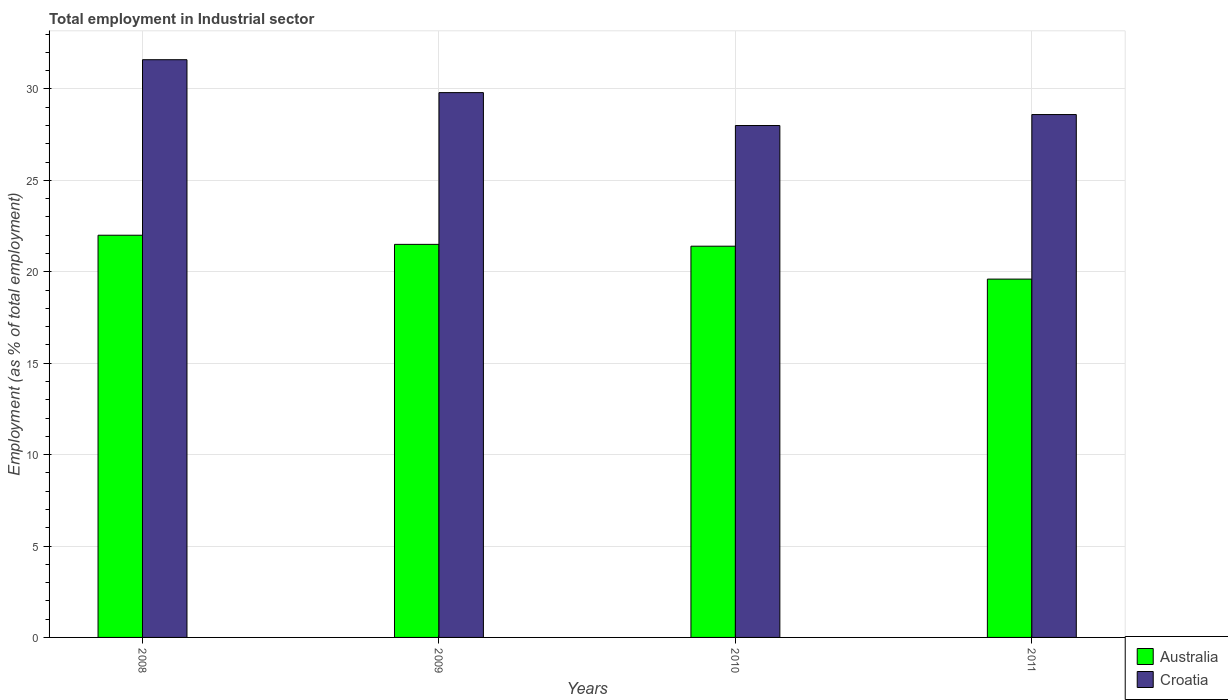How many groups of bars are there?
Make the answer very short. 4. Are the number of bars on each tick of the X-axis equal?
Offer a terse response. Yes. How many bars are there on the 1st tick from the right?
Keep it short and to the point. 2. What is the label of the 3rd group of bars from the left?
Offer a very short reply. 2010. In how many cases, is the number of bars for a given year not equal to the number of legend labels?
Provide a succinct answer. 0. What is the employment in industrial sector in Croatia in 2010?
Offer a very short reply. 28. Across all years, what is the minimum employment in industrial sector in Australia?
Provide a short and direct response. 19.6. What is the total employment in industrial sector in Croatia in the graph?
Provide a succinct answer. 118. What is the difference between the employment in industrial sector in Australia in 2009 and that in 2010?
Keep it short and to the point. 0.1. What is the difference between the employment in industrial sector in Croatia in 2011 and the employment in industrial sector in Australia in 2009?
Offer a terse response. 7.1. What is the average employment in industrial sector in Australia per year?
Your answer should be compact. 21.12. In the year 2008, what is the difference between the employment in industrial sector in Australia and employment in industrial sector in Croatia?
Give a very brief answer. -9.6. What is the ratio of the employment in industrial sector in Australia in 2008 to that in 2010?
Ensure brevity in your answer.  1.03. Is the employment in industrial sector in Australia in 2008 less than that in 2009?
Give a very brief answer. No. Is the difference between the employment in industrial sector in Australia in 2008 and 2009 greater than the difference between the employment in industrial sector in Croatia in 2008 and 2009?
Give a very brief answer. No. What is the difference between the highest and the lowest employment in industrial sector in Australia?
Provide a succinct answer. 2.4. Is the sum of the employment in industrial sector in Australia in 2009 and 2011 greater than the maximum employment in industrial sector in Croatia across all years?
Ensure brevity in your answer.  Yes. What does the 2nd bar from the left in 2011 represents?
Give a very brief answer. Croatia. How many bars are there?
Give a very brief answer. 8. Are all the bars in the graph horizontal?
Your response must be concise. No. What is the difference between two consecutive major ticks on the Y-axis?
Provide a short and direct response. 5. Does the graph contain any zero values?
Ensure brevity in your answer.  No. Does the graph contain grids?
Provide a succinct answer. Yes. Where does the legend appear in the graph?
Your answer should be compact. Bottom right. What is the title of the graph?
Offer a very short reply. Total employment in Industrial sector. What is the label or title of the Y-axis?
Provide a succinct answer. Employment (as % of total employment). What is the Employment (as % of total employment) of Australia in 2008?
Keep it short and to the point. 22. What is the Employment (as % of total employment) of Croatia in 2008?
Your response must be concise. 31.6. What is the Employment (as % of total employment) of Croatia in 2009?
Keep it short and to the point. 29.8. What is the Employment (as % of total employment) of Australia in 2010?
Your answer should be compact. 21.4. What is the Employment (as % of total employment) of Croatia in 2010?
Make the answer very short. 28. What is the Employment (as % of total employment) of Australia in 2011?
Keep it short and to the point. 19.6. What is the Employment (as % of total employment) of Croatia in 2011?
Ensure brevity in your answer.  28.6. Across all years, what is the maximum Employment (as % of total employment) of Australia?
Offer a terse response. 22. Across all years, what is the maximum Employment (as % of total employment) in Croatia?
Provide a short and direct response. 31.6. Across all years, what is the minimum Employment (as % of total employment) in Australia?
Make the answer very short. 19.6. Across all years, what is the minimum Employment (as % of total employment) in Croatia?
Ensure brevity in your answer.  28. What is the total Employment (as % of total employment) of Australia in the graph?
Make the answer very short. 84.5. What is the total Employment (as % of total employment) of Croatia in the graph?
Your response must be concise. 118. What is the difference between the Employment (as % of total employment) in Croatia in 2008 and that in 2009?
Keep it short and to the point. 1.8. What is the difference between the Employment (as % of total employment) in Croatia in 2009 and that in 2011?
Offer a very short reply. 1.2. What is the difference between the Employment (as % of total employment) in Croatia in 2010 and that in 2011?
Offer a terse response. -0.6. What is the difference between the Employment (as % of total employment) in Australia in 2008 and the Employment (as % of total employment) in Croatia in 2010?
Your response must be concise. -6. What is the difference between the Employment (as % of total employment) in Australia in 2010 and the Employment (as % of total employment) in Croatia in 2011?
Offer a terse response. -7.2. What is the average Employment (as % of total employment) in Australia per year?
Provide a short and direct response. 21.12. What is the average Employment (as % of total employment) in Croatia per year?
Offer a terse response. 29.5. In the year 2011, what is the difference between the Employment (as % of total employment) of Australia and Employment (as % of total employment) of Croatia?
Ensure brevity in your answer.  -9. What is the ratio of the Employment (as % of total employment) in Australia in 2008 to that in 2009?
Provide a succinct answer. 1.02. What is the ratio of the Employment (as % of total employment) of Croatia in 2008 to that in 2009?
Provide a short and direct response. 1.06. What is the ratio of the Employment (as % of total employment) of Australia in 2008 to that in 2010?
Keep it short and to the point. 1.03. What is the ratio of the Employment (as % of total employment) of Croatia in 2008 to that in 2010?
Offer a terse response. 1.13. What is the ratio of the Employment (as % of total employment) of Australia in 2008 to that in 2011?
Offer a very short reply. 1.12. What is the ratio of the Employment (as % of total employment) in Croatia in 2008 to that in 2011?
Provide a short and direct response. 1.1. What is the ratio of the Employment (as % of total employment) of Australia in 2009 to that in 2010?
Make the answer very short. 1. What is the ratio of the Employment (as % of total employment) of Croatia in 2009 to that in 2010?
Offer a terse response. 1.06. What is the ratio of the Employment (as % of total employment) of Australia in 2009 to that in 2011?
Ensure brevity in your answer.  1.1. What is the ratio of the Employment (as % of total employment) in Croatia in 2009 to that in 2011?
Make the answer very short. 1.04. What is the ratio of the Employment (as % of total employment) in Australia in 2010 to that in 2011?
Offer a terse response. 1.09. 